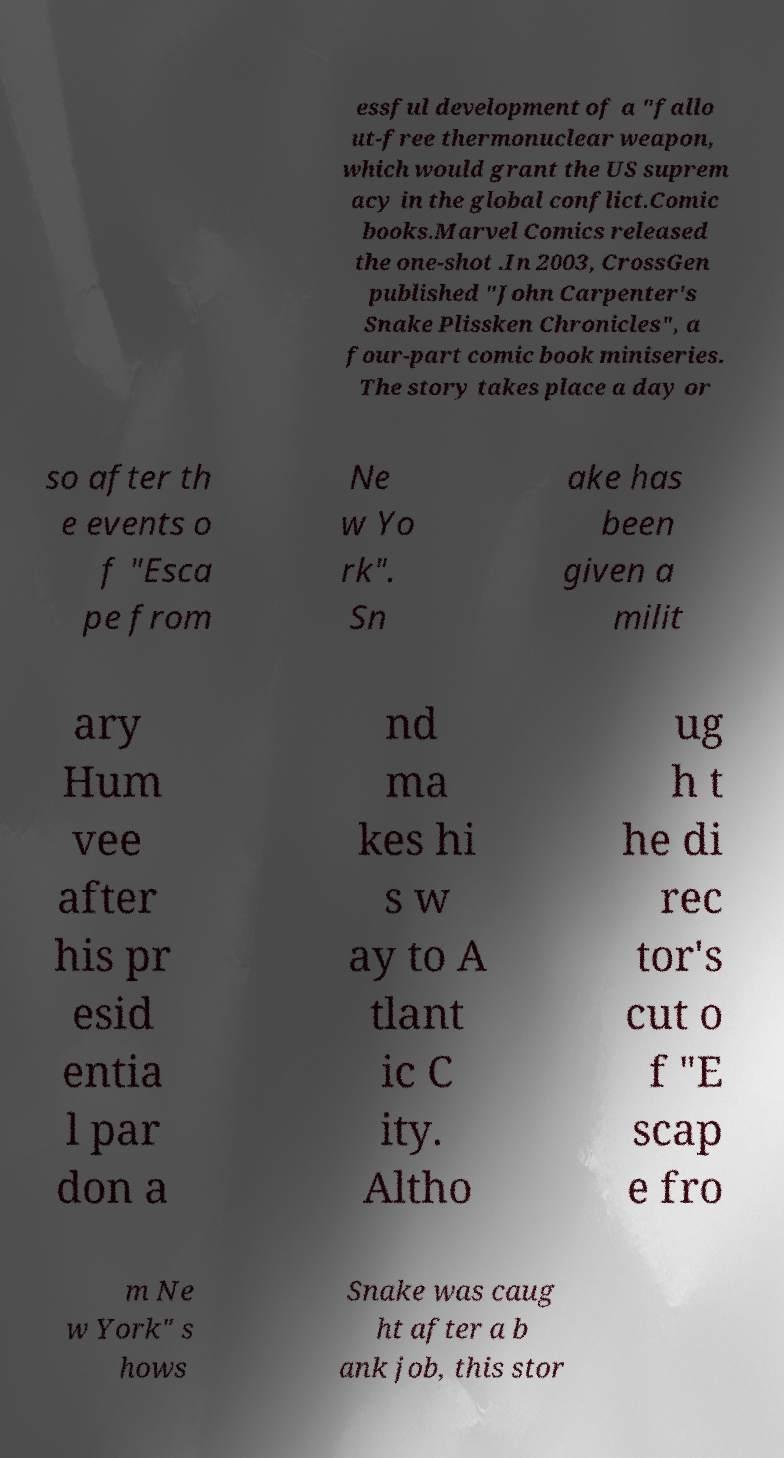Can you accurately transcribe the text from the provided image for me? essful development of a "fallo ut-free thermonuclear weapon, which would grant the US suprem acy in the global conflict.Comic books.Marvel Comics released the one-shot .In 2003, CrossGen published "John Carpenter's Snake Plissken Chronicles", a four-part comic book miniseries. The story takes place a day or so after th e events o f "Esca pe from Ne w Yo rk". Sn ake has been given a milit ary Hum vee after his pr esid entia l par don a nd ma kes hi s w ay to A tlant ic C ity. Altho ug h t he di rec tor's cut o f "E scap e fro m Ne w York" s hows Snake was caug ht after a b ank job, this stor 